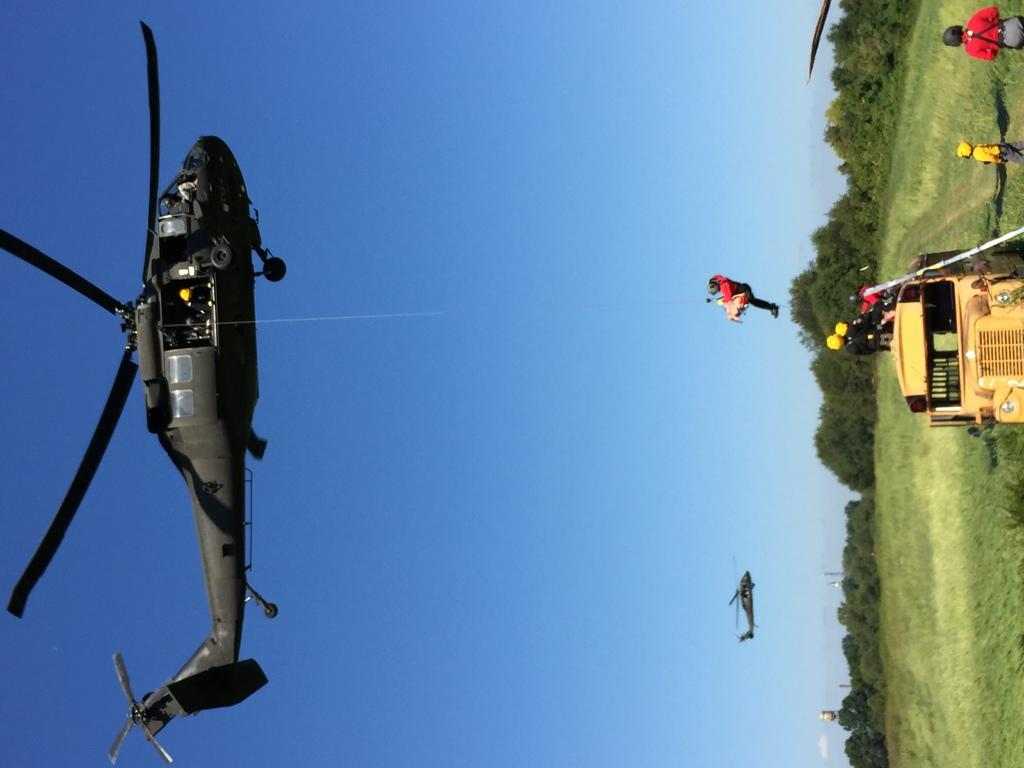What type of vehicles are in the image? There are helicopters in the image. Can you describe the people in the image? There is a group of people in the image. Where is the truck located in the image? The truck is on the grass in the image. What can be seen in the background of the image? Trees are present in the background of the image. What type of drawer can be seen in the image? There is no drawer present in the image. How does the digestion of the people in the image affect the helicopters? There is no information about the people's digestion in the image, and it does not affect the helicopters. 